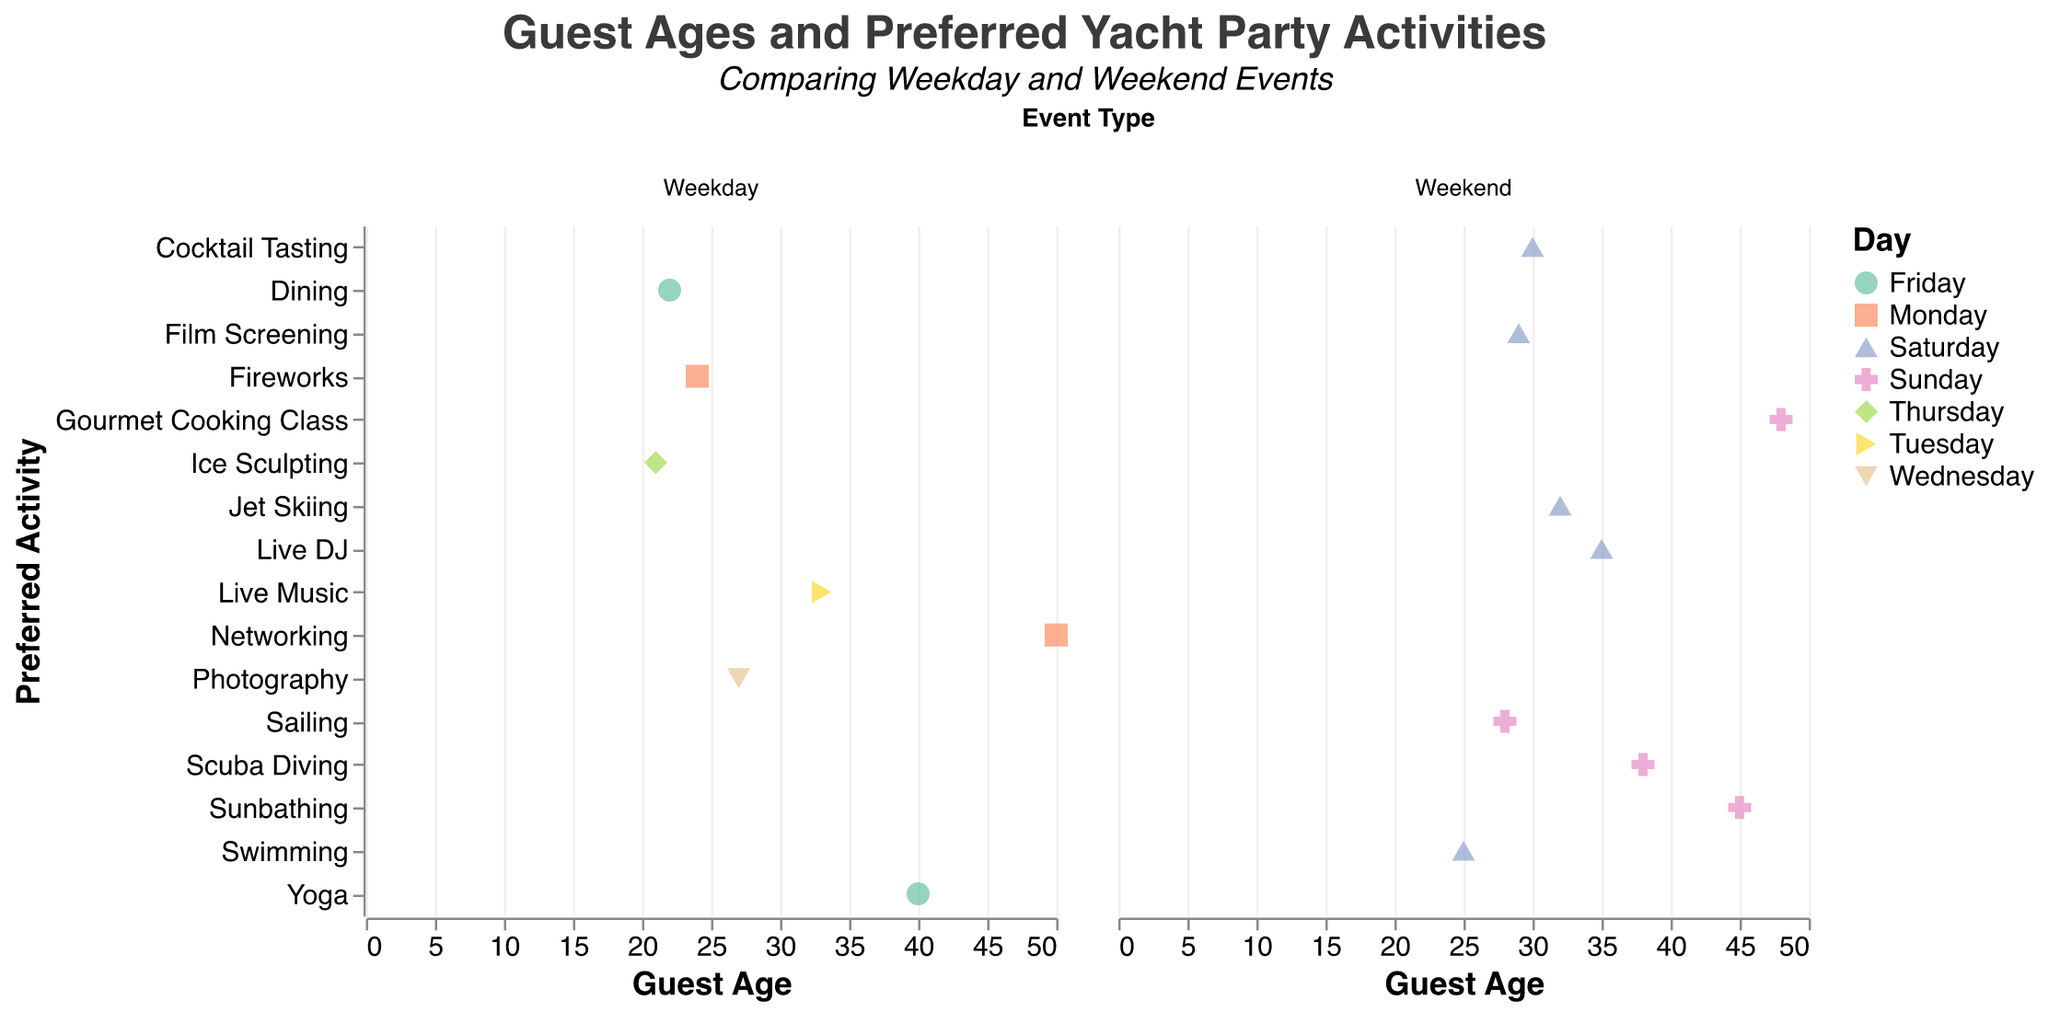What is the title of the figure? The title of the figure is located at the top and provides the main subject of the plot. It is "Guest Ages and Preferred Yacht Party Activities."
Answer: Guest Ages and Preferred Yacht Party Activities How are Weekday and Weekend events visually separated in the plot? The plot uses faceting to separate the data into two columns. One column represents Weekday events, and the other represents Weekend events.
Answer: Faceting Which activity is preferred by the youngest guest for a Weekend event? The plot shows that for Weekend events, the points corresponding to the youngest guest (age 25) are linked to the activity "Swimming" on Saturdays.
Answer: Swimming Is the age range of guests broader for Weekday or Weekend events? To answer this, we need to compare the range of ages in both columns. The Weekday column shows an age range from 21 to 50, while the Weekend column shows a range from 25 to 48. Weekday events cover more age ranges.
Answer: Weekday Which activity on a Weekday is preferred by guests in their twenties? Refer to the Weekday column and look for activities corresponding to guests in their twenties. The activities are "Dining" for age 22 and "Photography" for age 27.
Answer: Dining, Photography Compare the preferred activities for guests in their 30s for Weekday and Weekend events. Check both columns for activities linked to ages in the 30s. For Weekdays, guests in their 30s prefer "Live Music." For Weekends, the activities include "Live DJ," "Jet Skiing," and "Cocktail Tasting."
Answer: Live Music (Weekday), Live DJ, Jet Skiing, Cocktail Tasting (Weekend) What is the most complex activity preferred during Weekend events? Complexity can be subjective, but activities such as "Scuba Diving" and "Gourmet Cooking Class" require more skills and preparation compared to others.
Answer: Scuba Diving, Gourmet Cooking Class Which day of the week has the most varied activities? Examine the number of different activities per day in the plot. Saturday has the most varied activities during Weekend events: "Swimming," "Cocktail Tasting," "Live DJ," "Jet Skiing," and "Film Screening."
Answer: Saturday What is the median age of guests attending Weekend events? List the ages for Weekend events: 25, 30, 35, 28, 45, 32, 38, 29, and 48. Arranging these in order: 25, 28, 29, 30, 32, 35, 38, 45, 48. The median age is the middle value, 32.
Answer: 32 Are there more guests in their 20s during Weekday or Weekend events? Check the plot for the number of guests aged between 20-29. For Weekdays, there are two: ages 22 and 27. For Weekends, there are four: ages 25, 28, 29, and 27.
Answer: Weekend 